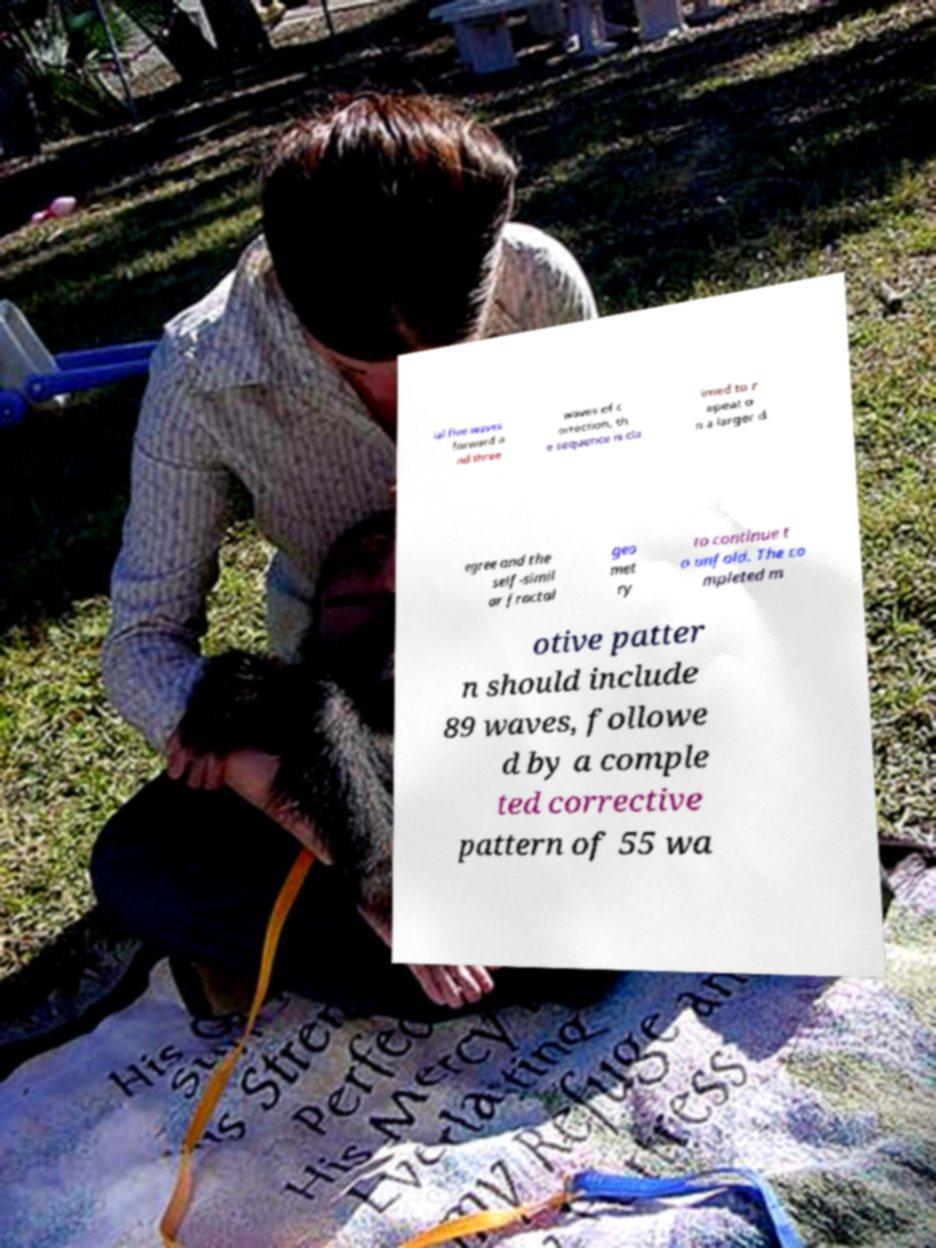Please identify and transcribe the text found in this image. ial five waves forward a nd three waves of c orrection, th e sequence is cla imed to r epeat o n a larger d egree and the self-simil ar fractal geo met ry to continue t o unfold. The co mpleted m otive patter n should include 89 waves, followe d by a comple ted corrective pattern of 55 wa 